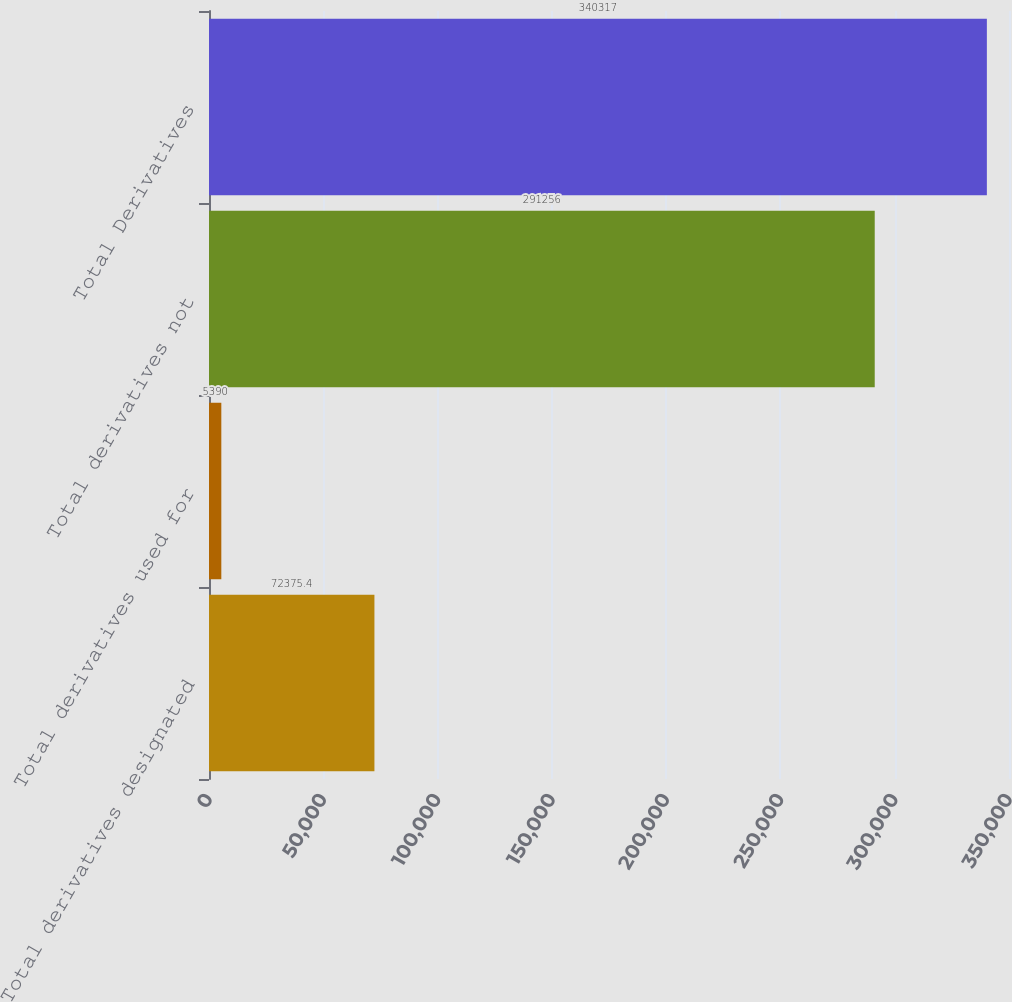Convert chart. <chart><loc_0><loc_0><loc_500><loc_500><bar_chart><fcel>Total derivatives designated<fcel>Total derivatives used for<fcel>Total derivatives not<fcel>Total Derivatives<nl><fcel>72375.4<fcel>5390<fcel>291256<fcel>340317<nl></chart> 